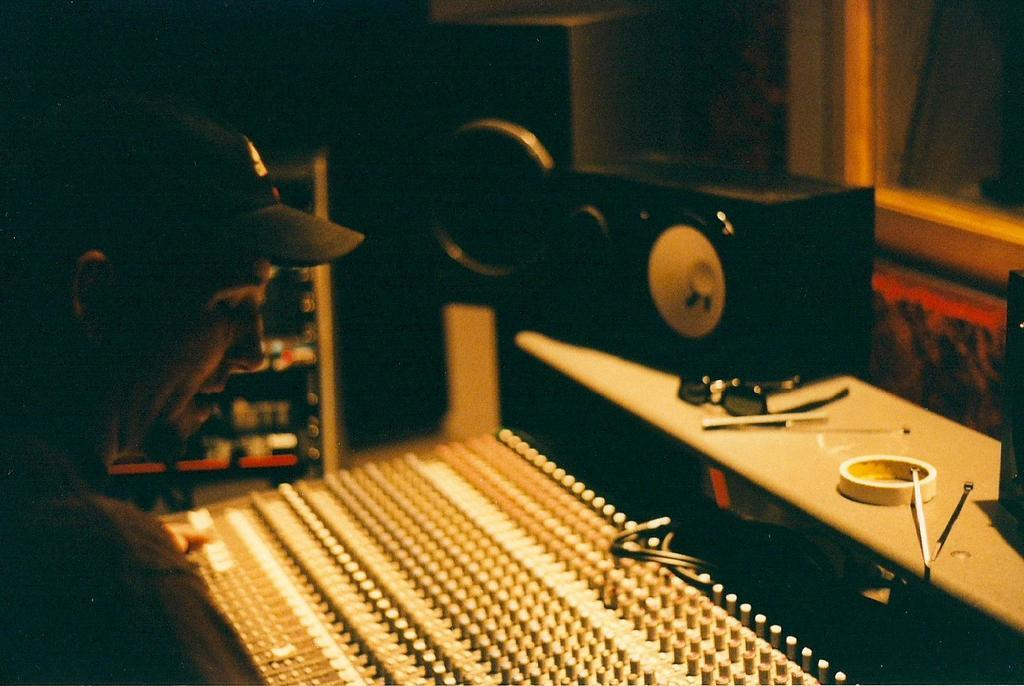Who or what is in the image? There is a person in the image. What is the person doing or interacting with? There is a musical instrument in front of the person. What else can be seen in the image? There are objects on a table in the image. What might be used for amplifying sound in the image? There is a speaker in the image. What day of the week is depicted in the image? The image does not depict a specific day of the week; it is a still image of a person with a musical instrument and other objects. 